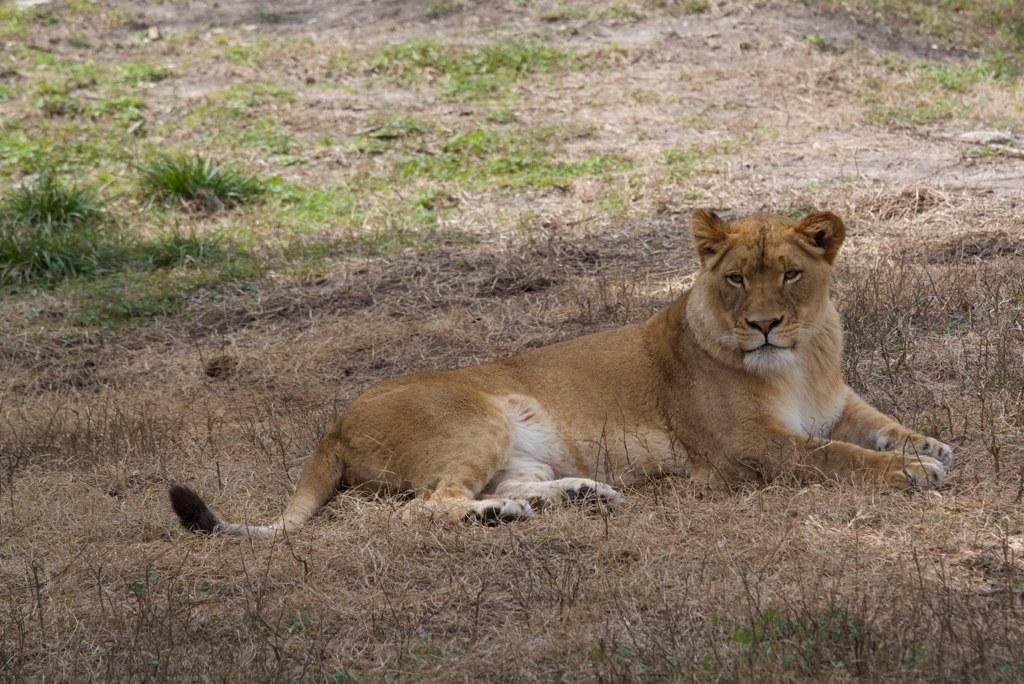What animal is the main subject of the image? There is a brown color lion in the image. What is the lion sitting on? The lion is sitting on dry grass. Where is the dry grass located? The dry grass is on the ground. What can be seen in the background of the image? In the background, there is green-colored grass on the ground. Can you see a swing in the image? No, there is no swing present in the image. Are there any cherries visible in the image? No, there are no cherries visible in the image. 